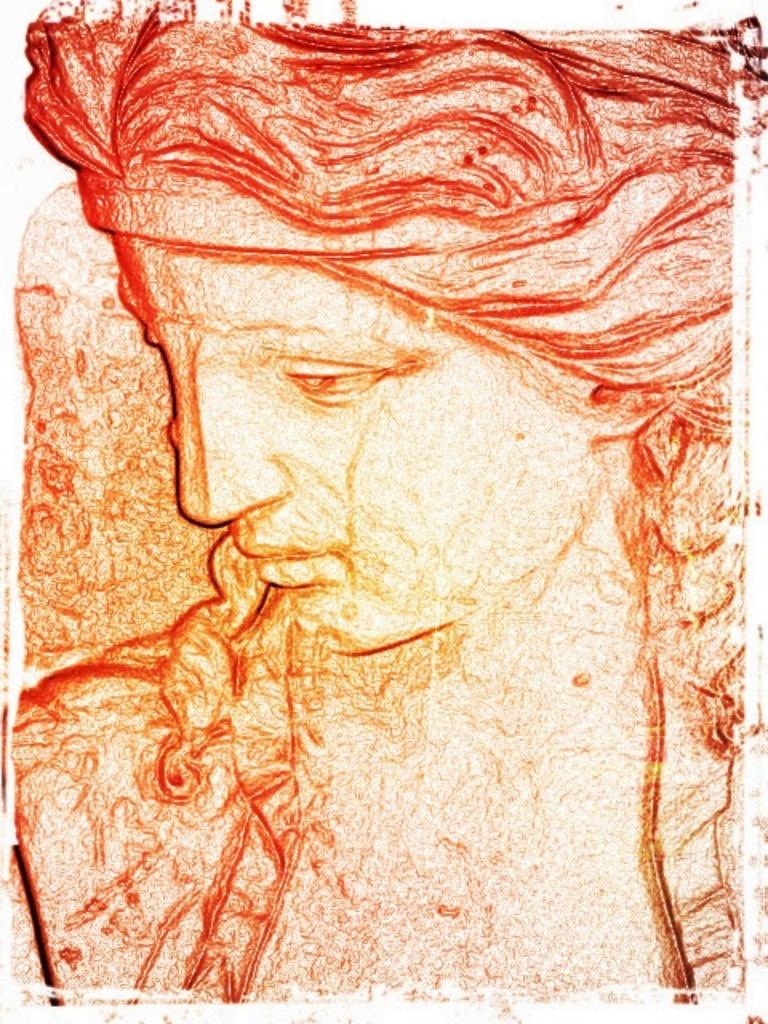What is the main subject of the image? The image contains a painting. What is depicted in the painting? The painting depicts a woman. Can you see any cactus plants providing comfort to the woman in the painting? There is no mention of cactus plants or any other objects in the painting, so it cannot be determined if they are present or providing comfort. 